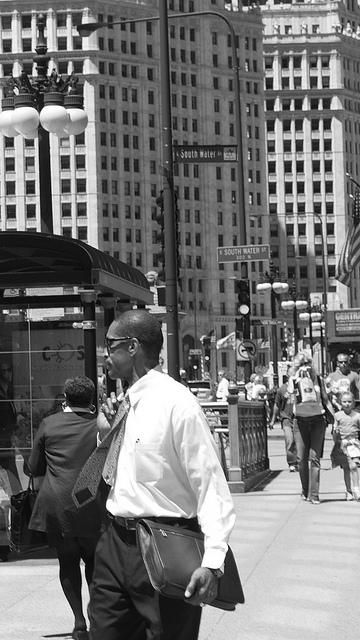What does the fenced in area behind the man lead to? subway 